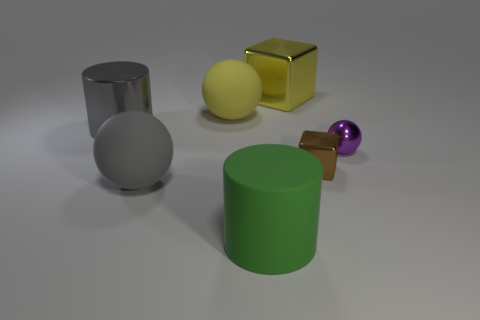Is the number of large gray shiny cylinders that are right of the yellow rubber ball greater than the number of gray metal things?
Offer a terse response. No. Does the green rubber object have the same shape as the tiny brown thing?
Make the answer very short. No. How many green things have the same material as the purple sphere?
Provide a succinct answer. 0. There is a gray thing that is the same shape as the big green matte object; what is its size?
Your answer should be compact. Large. Is the matte cylinder the same size as the gray rubber sphere?
Provide a short and direct response. Yes. The object in front of the big sphere that is in front of the cylinder that is left of the yellow rubber sphere is what shape?
Ensure brevity in your answer.  Cylinder. What is the color of the other thing that is the same shape as the big yellow shiny object?
Make the answer very short. Brown. There is a rubber object that is on the right side of the big gray ball and in front of the small brown shiny cube; what is its size?
Your answer should be very brief. Large. What number of big balls are right of the yellow metallic block that is behind the gray metal object behind the large green matte object?
Your answer should be compact. 0. What number of large objects are either gray things or yellow matte objects?
Ensure brevity in your answer.  3. 